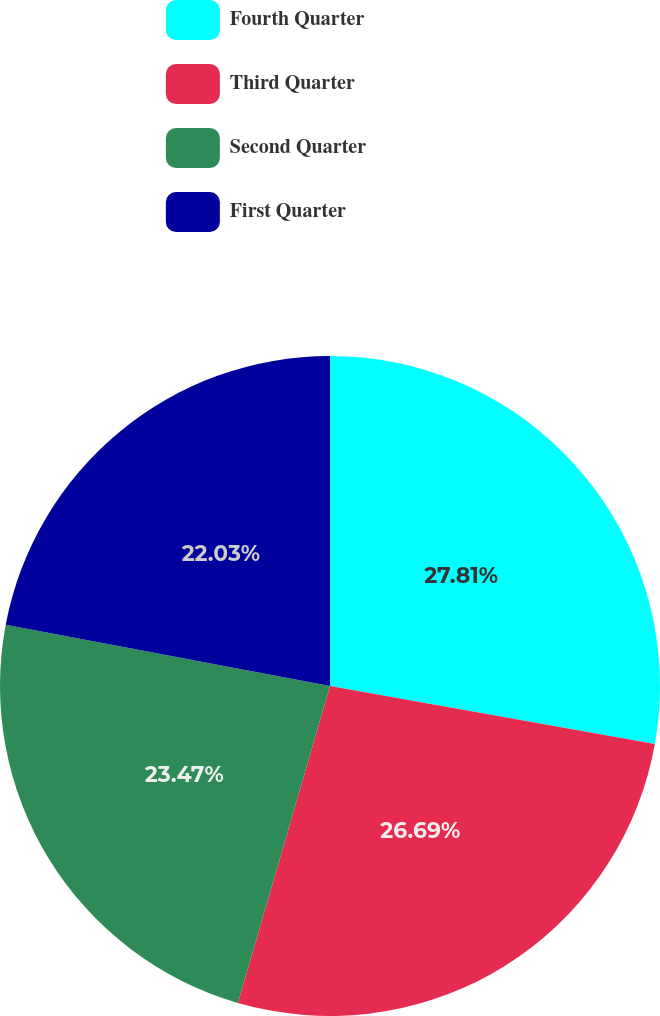<chart> <loc_0><loc_0><loc_500><loc_500><pie_chart><fcel>Fourth Quarter<fcel>Third Quarter<fcel>Second Quarter<fcel>First Quarter<nl><fcel>27.81%<fcel>26.69%<fcel>23.47%<fcel>22.03%<nl></chart> 